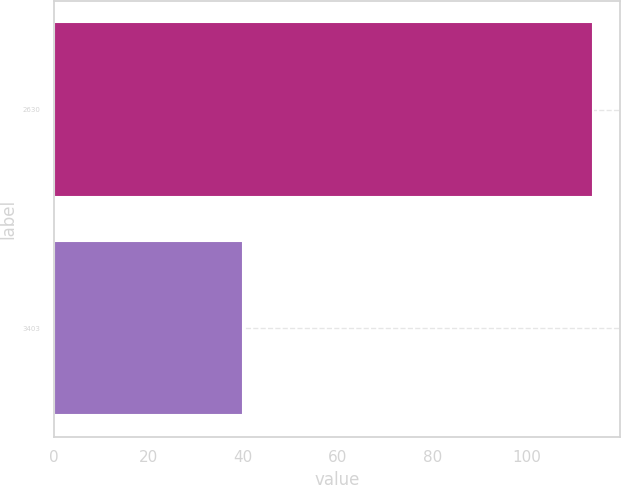Convert chart. <chart><loc_0><loc_0><loc_500><loc_500><bar_chart><fcel>2630<fcel>3403<nl><fcel>114<fcel>40<nl></chart> 